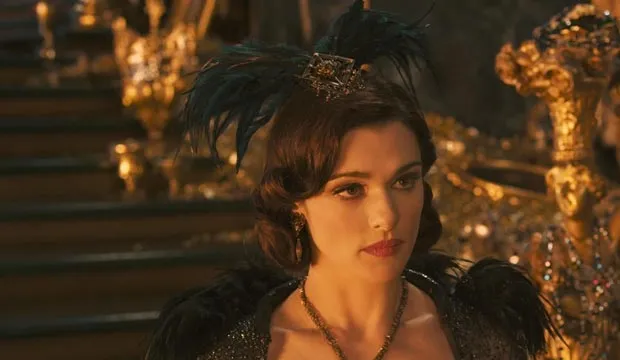Describe a casual conversation Evanora might have. Evanora sits in a luxurious parlor, sipping tea from a delicate porcelain cup. Engaging in a casual conversation with her sister, Theodora, she speaks of the beauty of the Emerald City and the latest fashions among the elite. Despite the light-hearted topic, there is an underlying tension in her voice, a reminder of the constant power struggle she is embroiled in. 